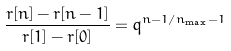Convert formula to latex. <formula><loc_0><loc_0><loc_500><loc_500>\frac { r [ n ] - r [ n - 1 ] } { r [ 1 ] - r [ 0 ] } = q ^ { n - 1 / n _ { \max } - 1 }</formula> 